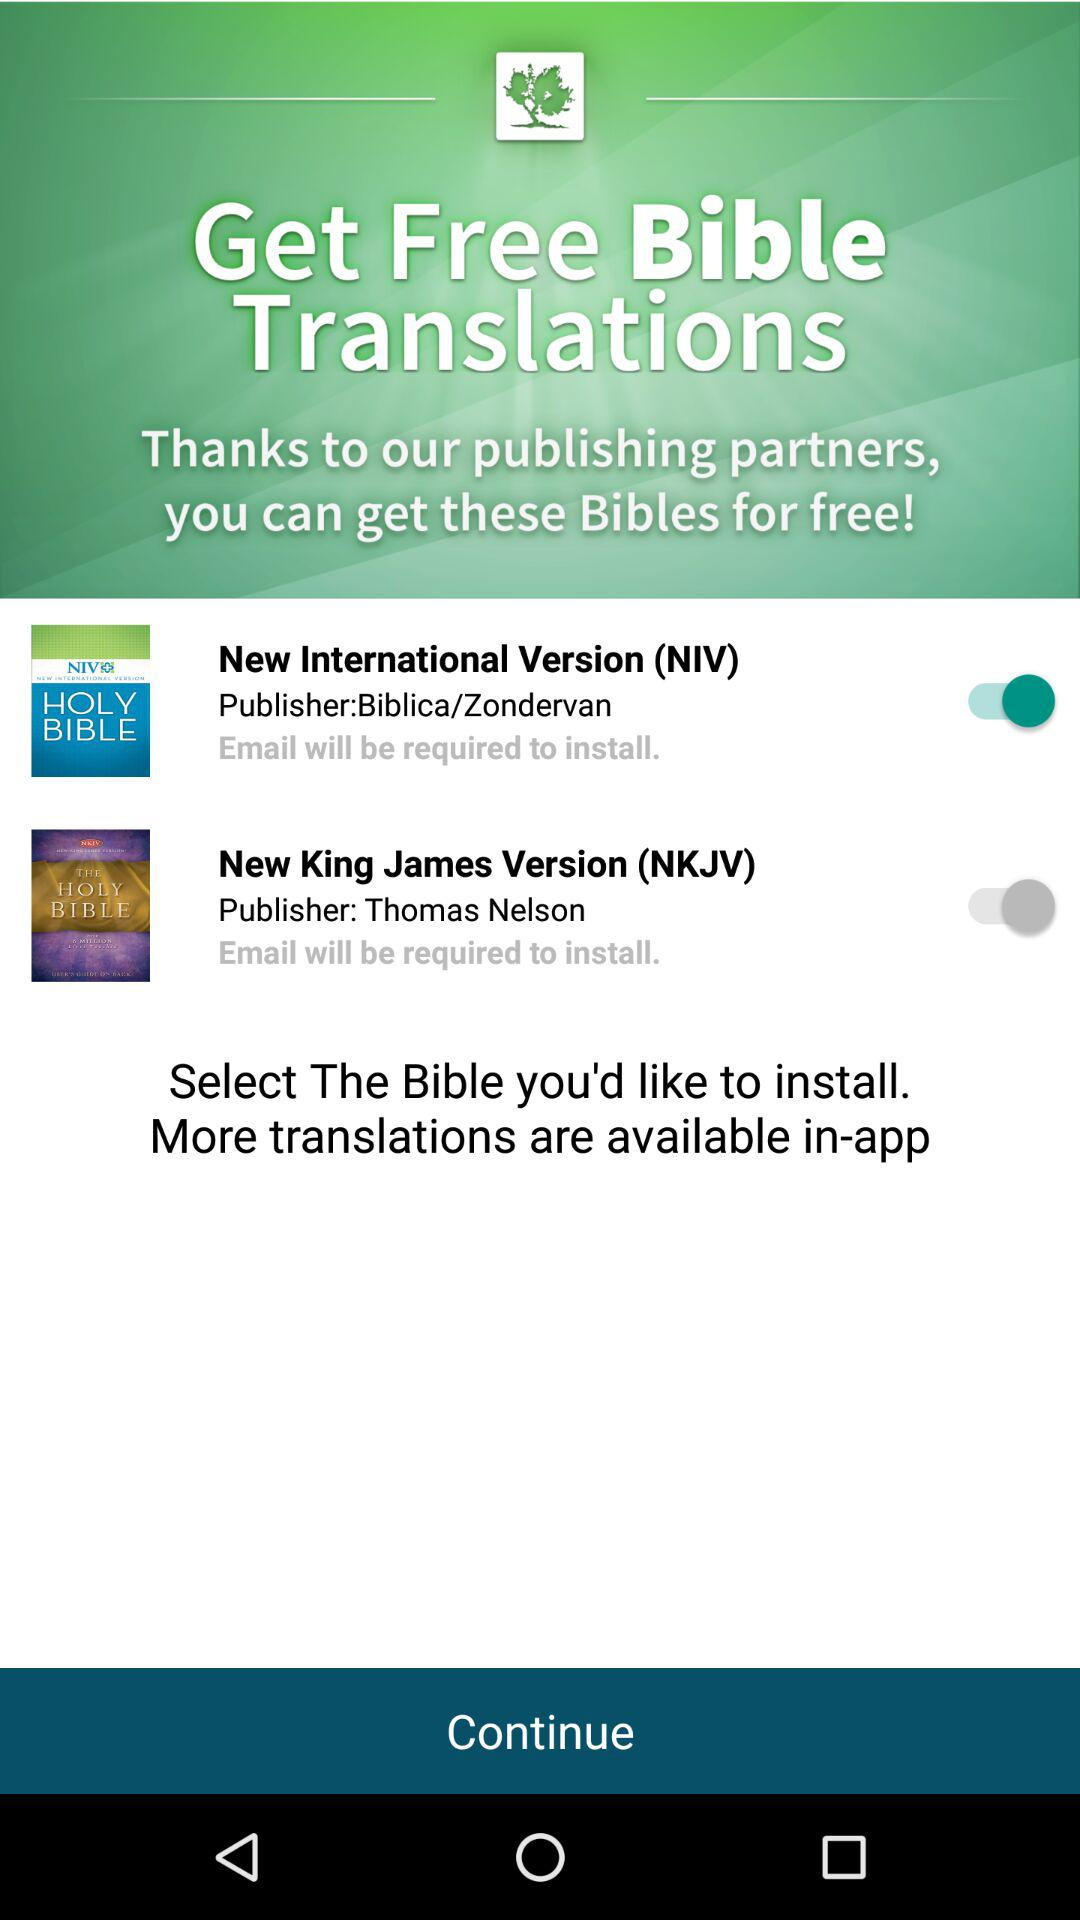How many Bible translations are available for free?
Answer the question using a single word or phrase. 2 